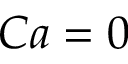Convert formula to latex. <formula><loc_0><loc_0><loc_500><loc_500>C a = 0</formula> 